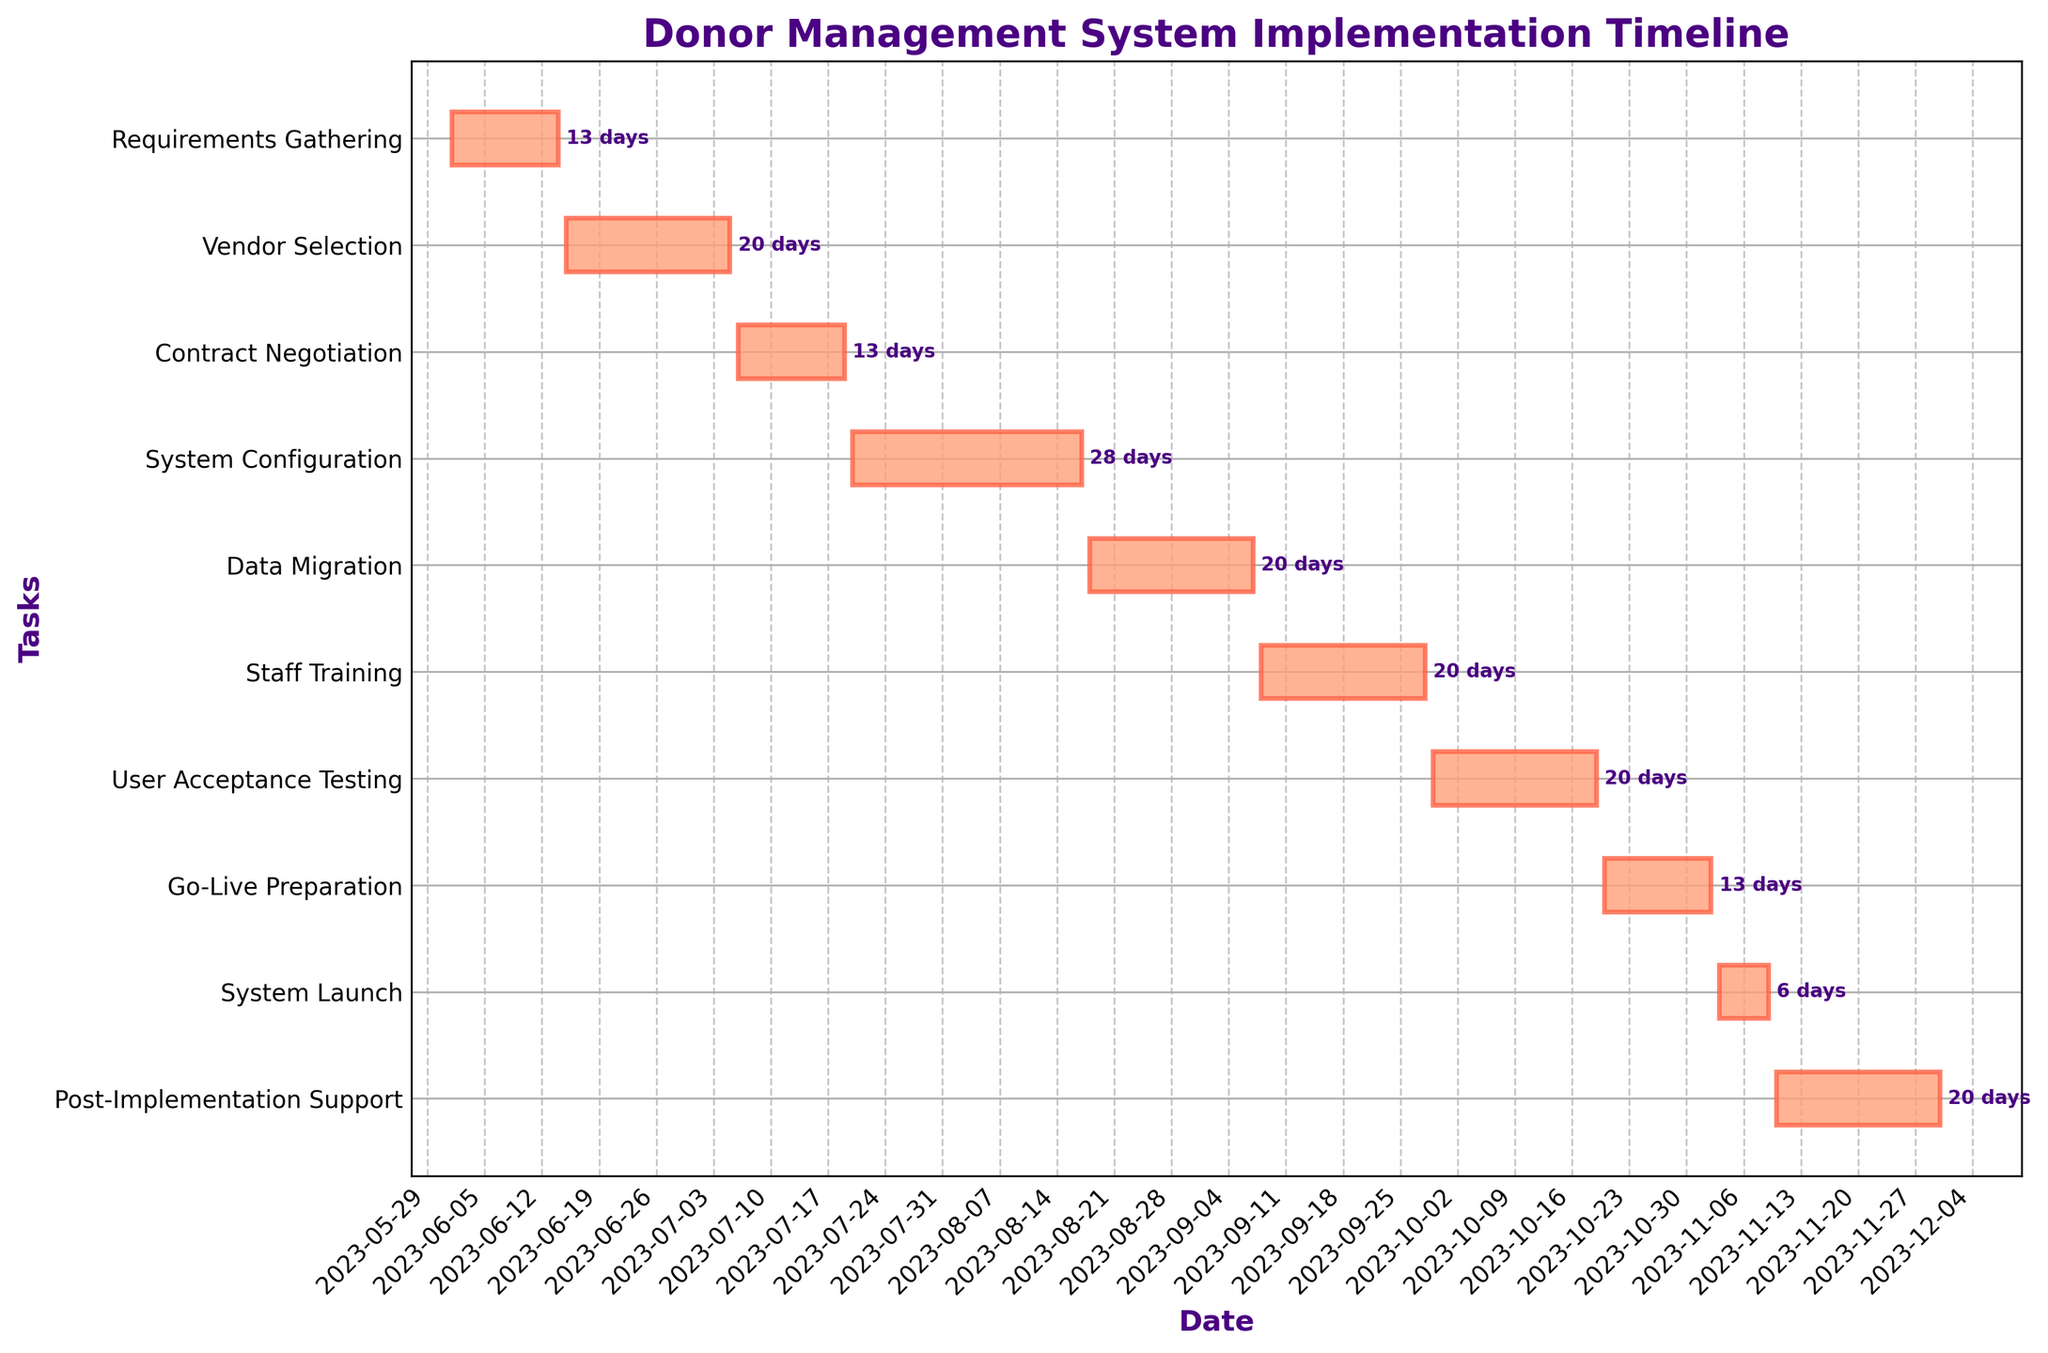What is the title of the Gantt chart? The title is located at the top of the chart and is typically in a larger, bold font to stand out.
Answer: Donor Management System Implementation Timeline Which task has the longest duration? Check the length of each bar on the Gantt chart. The longest bar represents the task with the longest duration.
Answer: System Configuration How many tasks are scheduled for September? Identify the tasks with bars that span any part of September by checking their start and end dates against the month of September on the x-axis.
Answer: 3 What is the duration of "Staff Training"? Look at the bar labeled "Staff Training," and refer to the text label next to the bar or calculate the difference between the start and end dates of the task.
Answer: 21 days Which tasks have the same duration? Compare the length of the bars and/or the text labels next to the bars to find tasks with the same duration.
Answer: Vendor Selection, Data Migration, Staff Training, User Acceptance Testing, Post-Implementation Support When does the "System Launch" task start and end? Refer to the bar labeled "System Launch" and check its start and end points along the date axis. The start and end dates are usually shown alongside the bar.
Answer: 2023-11-03 to 2023-11-09 What is the total duration of the project from start to end? Identify the earliest start date and the latest end date on the x-axis. Calculate the difference between these two dates to get the total duration.
Answer: 183 days Which task is scheduled to end first? Find the bar that ends the earliest based on the position along the x-axis. This will indicate the first task to finish.
Answer: Requirements Gathering Are there any tasks scheduled for October? Check the start and end dates of all tasks and see which ones overlap with October on the x-axis.
Answer: Yes How does the "System Configuration" task compare in duration to the "Contract Negotiation" task? Compare the lengths of the bars for "System Configuration" and "Contract Negotiation" or refer to their duration text labels.
Answer: System Configuration is longer 